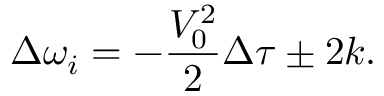<formula> <loc_0><loc_0><loc_500><loc_500>\Delta \omega _ { i } = - \frac { V _ { 0 } ^ { 2 } } { 2 } \Delta \tau \pm 2 k .</formula> 